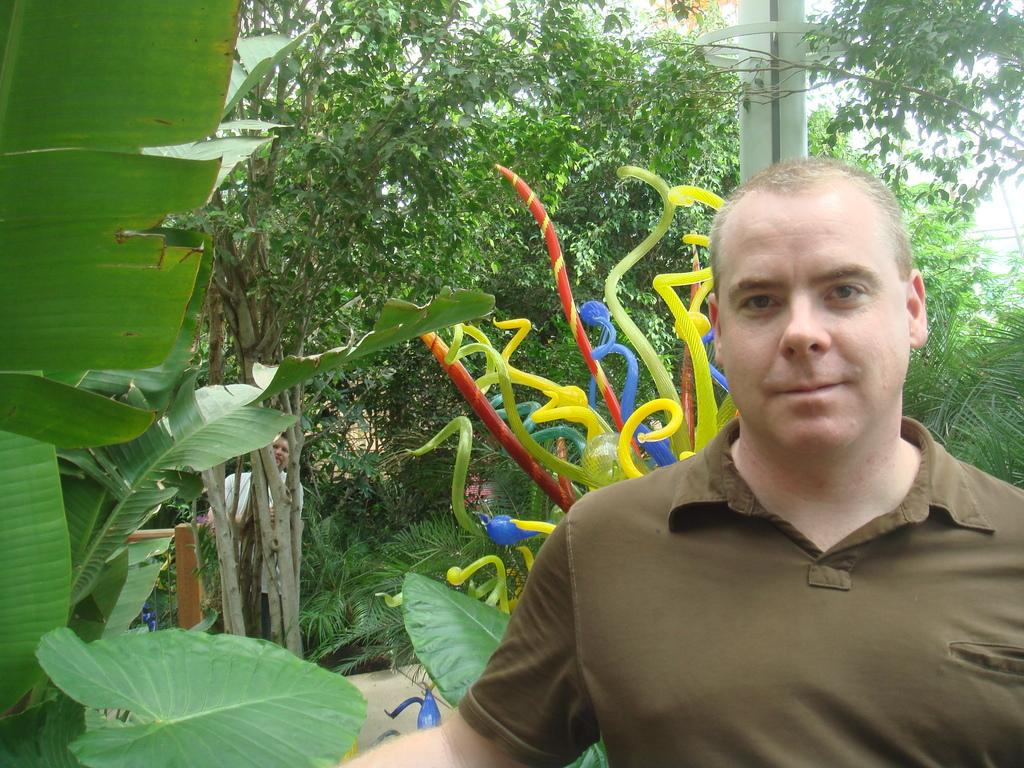What is the main subject in the foreground of the picture? There is a person in the foreground of the picture. What can be seen on the left side of the picture? There are trees on the left side of the picture. What is located in the center of the picture? There are some objects in the center of the picture. What is visible in the background of the picture? There are trees and a pole in the background of the picture. What type of scissors can be seen cutting the edge of the scene in the image? There are no scissors or cutting visible in the image; it features a person, trees, and objects. 